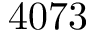Convert formula to latex. <formula><loc_0><loc_0><loc_500><loc_500>4 0 7 3</formula> 